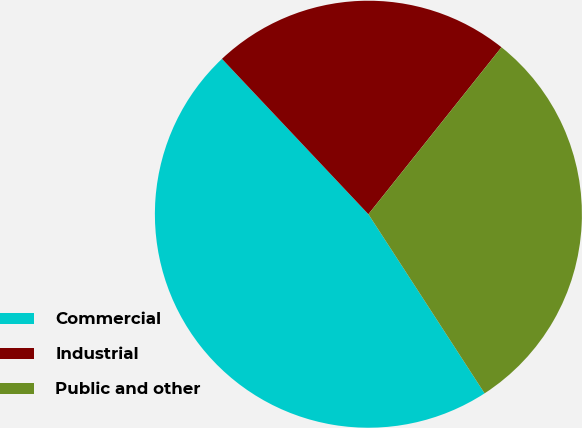Convert chart to OTSL. <chart><loc_0><loc_0><loc_500><loc_500><pie_chart><fcel>Commercial<fcel>Industrial<fcel>Public and other<nl><fcel>47.13%<fcel>22.74%<fcel>30.13%<nl></chart> 